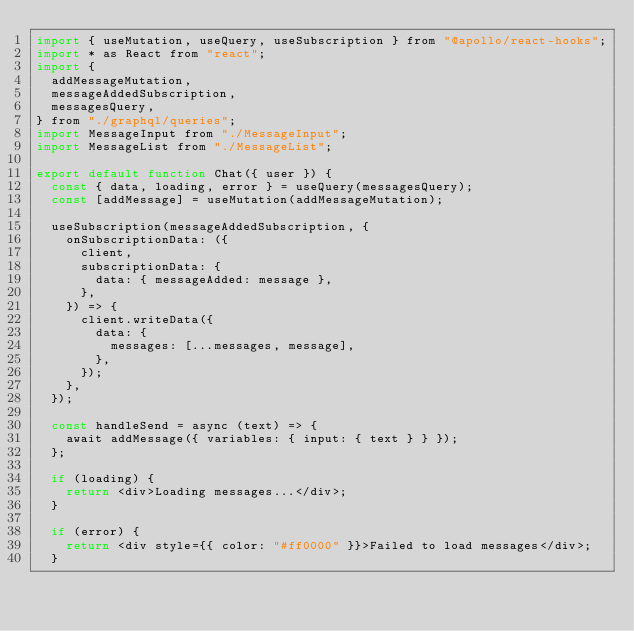<code> <loc_0><loc_0><loc_500><loc_500><_JavaScript_>import { useMutation, useQuery, useSubscription } from "@apollo/react-hooks";
import * as React from "react";
import {
  addMessageMutation,
  messageAddedSubscription,
  messagesQuery,
} from "./graphql/queries";
import MessageInput from "./MessageInput";
import MessageList from "./MessageList";

export default function Chat({ user }) {
  const { data, loading, error } = useQuery(messagesQuery);
  const [addMessage] = useMutation(addMessageMutation);

  useSubscription(messageAddedSubscription, {
    onSubscriptionData: ({
      client,
      subscriptionData: {
        data: { messageAdded: message },
      },
    }) => {
      client.writeData({
        data: {
          messages: [...messages, message],
        },
      });
    },
  });

  const handleSend = async (text) => {
    await addMessage({ variables: { input: { text } } });
  };

  if (loading) {
    return <div>Loading messages...</div>;
  }

  if (error) {
    return <div style={{ color: "#ff0000" }}>Failed to load messages</div>;
  }
</code> 